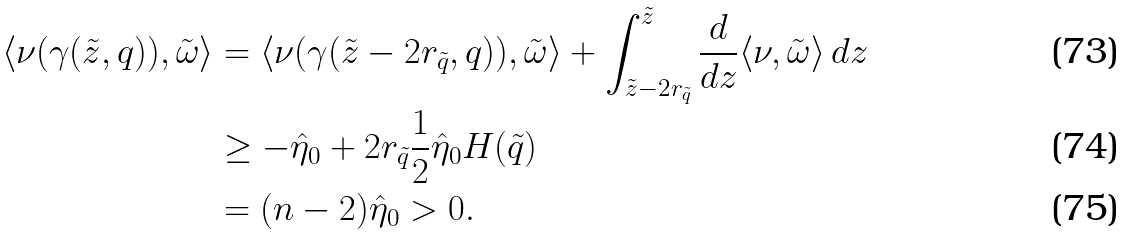Convert formula to latex. <formula><loc_0><loc_0><loc_500><loc_500>\langle \nu ( \gamma ( \tilde { z } , q ) ) , \tilde { \omega } \rangle & = \langle \nu ( \gamma ( \tilde { z } - 2 r _ { \tilde { q } } , q ) ) , \tilde { \omega } \rangle + \int _ { \tilde { z } - 2 r _ { \tilde { q } } } ^ { \tilde { z } } \frac { d } { d z } \langle \nu , \tilde { \omega } \rangle \, d z \\ & \geq - \hat { \eta } _ { 0 } + 2 r _ { \tilde { q } } \frac { 1 } { 2 } \hat { \eta } _ { 0 } H ( \tilde { q } ) \\ & = ( n - 2 ) \hat { \eta } _ { 0 } > 0 .</formula> 